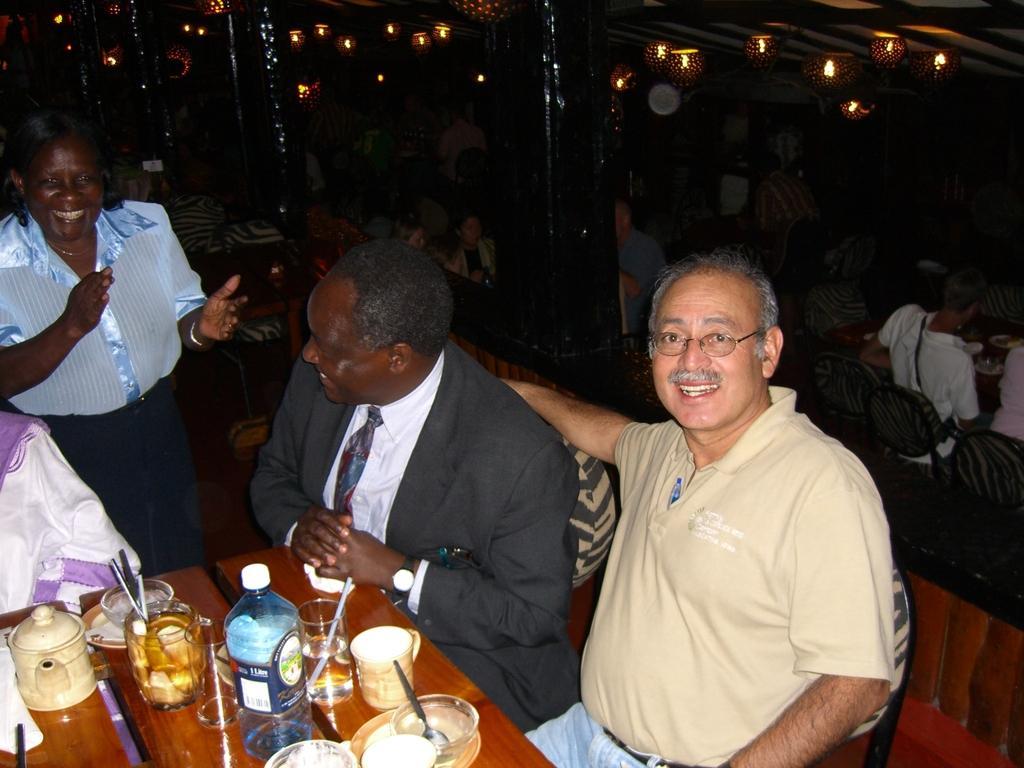Can you describe this image briefly? In this image few persons are sitting before a table having kettle, plate, glasses, jar and cup are on it. Glass and jar are filled with drink and having a straw in it. Plate is having a bowl which is having a spoon in it. A person wearing a black suit is wearing a tie. He is sitting on the chair. Beside there is a person standing on the floor. Few lights are attached to the roof. 